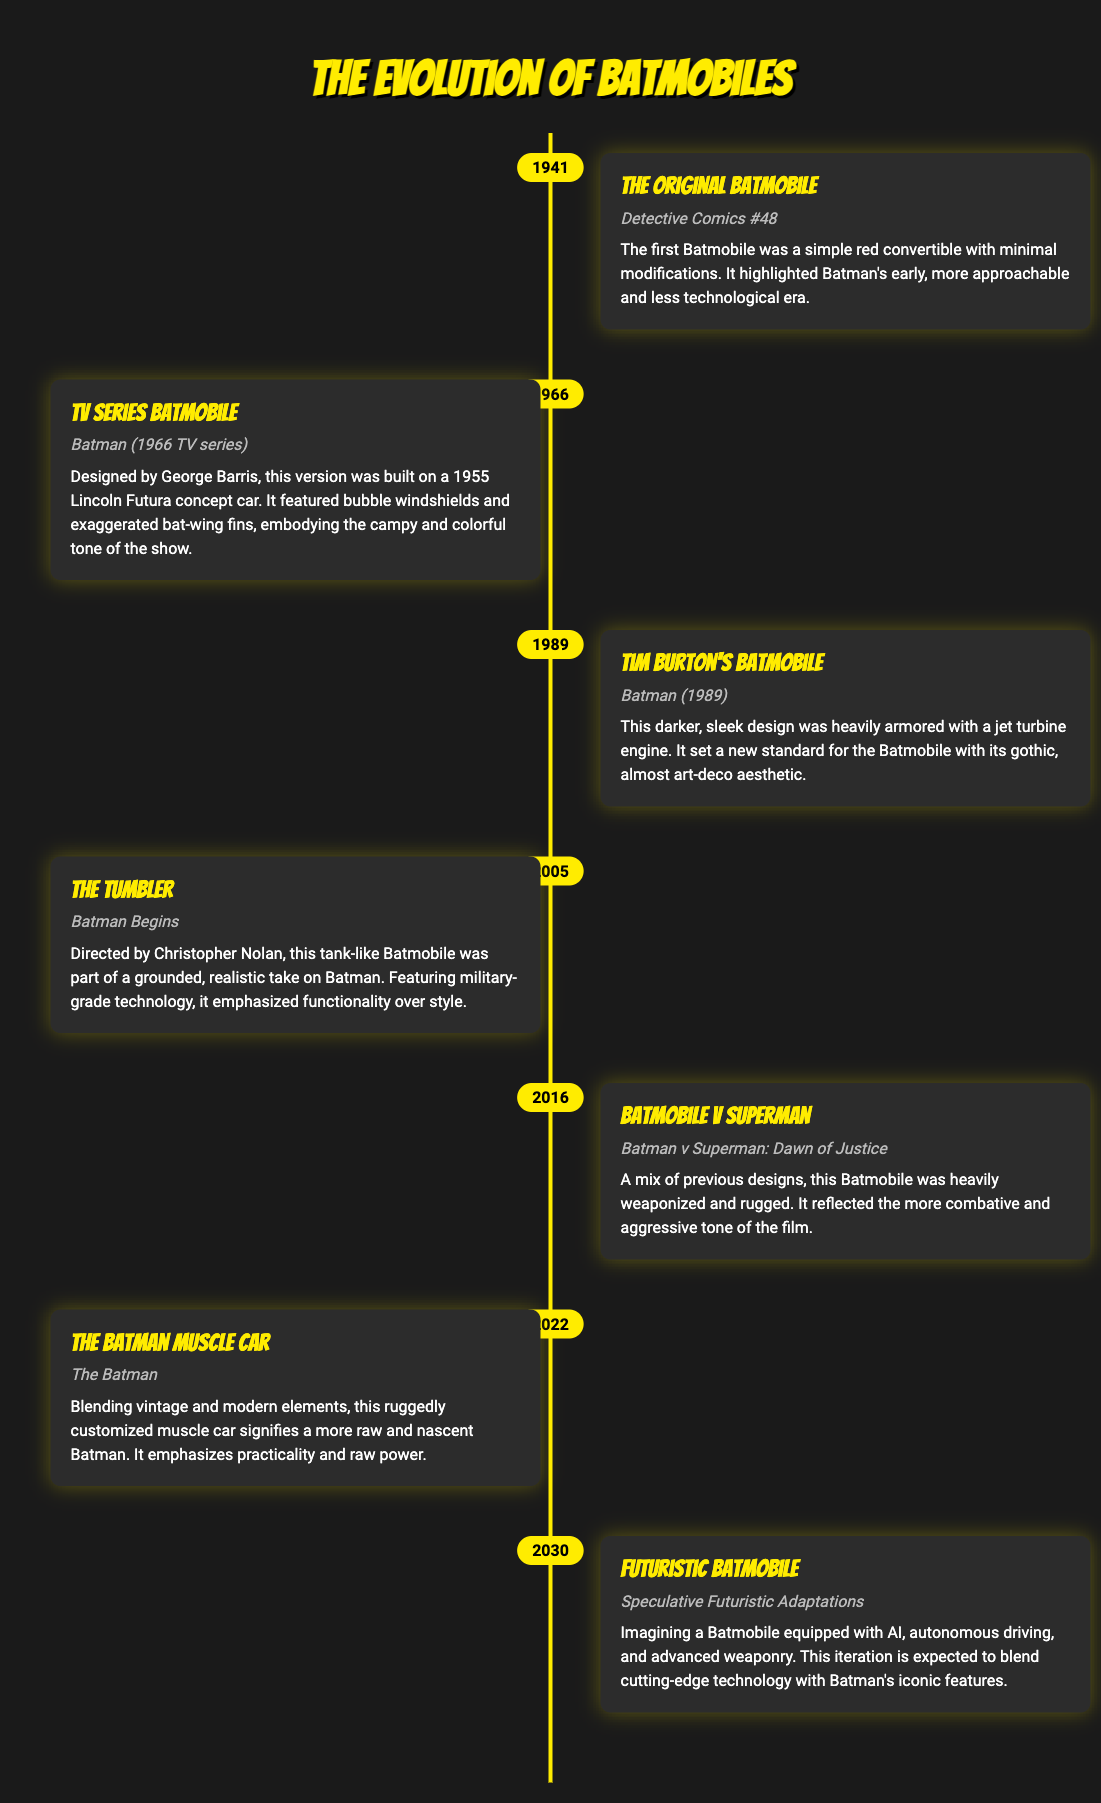What year was the Original Batmobile introduced? The Original Batmobile was first introduced in Detective Comics #48, which was published in 1941.
Answer: 1941 Who designed the TV Series Batmobile? The TV Series Batmobile was designed by George Barris for the 1966 Batman TV series.
Answer: George Barris What was a distinctive feature of Tim Burton's Batmobile? Tim Burton's Batmobile had a sleek design heavily armored with a jet turbine engine, which set a new standard for the Batmobile.
Answer: Jet turbine engine In which film did the Tumbler appear? The Tumbler appeared in the film Batman Begins, directed by Christopher Nolan.
Answer: Batman Begins How does the 2022 Batmobile describe its characteristics? The 2022 Batmobile is described as a ruggedly customized muscle car that emphasizes practicality and raw power.
Answer: Ruggedly customized muscle car What is the expected feature of the Futuristic Batmobile? The Futuristic Batmobile is expected to be equipped with AI and autonomous driving capabilities.
Answer: AI What major thematic change does the Batmobile V Superman reflect? The Batmobile V Superman reflects a more combative and aggressive tone in its design and features.
Answer: Combative and aggressive How many years span between the Original Batmobile and the Futuristic Batmobile? The Original Batmobile was introduced in 1941, and the Futuristic Batmobile is speculative for 2030, spanning 89 years.
Answer: 89 years 